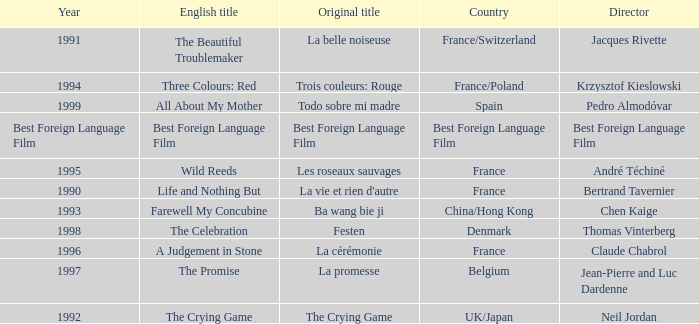Which Country is listed for the Director Thomas Vinterberg? Denmark. 